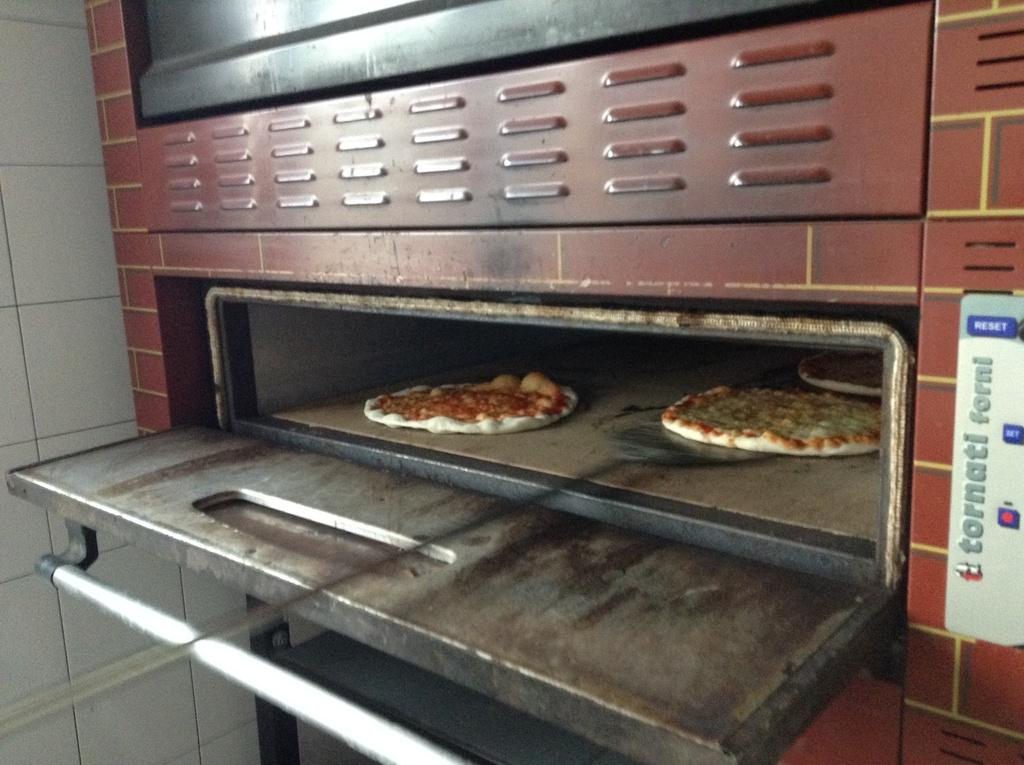<image>
Offer a succinct explanation of the picture presented. A Tornati Forni oven is open and pizzas are inside. 